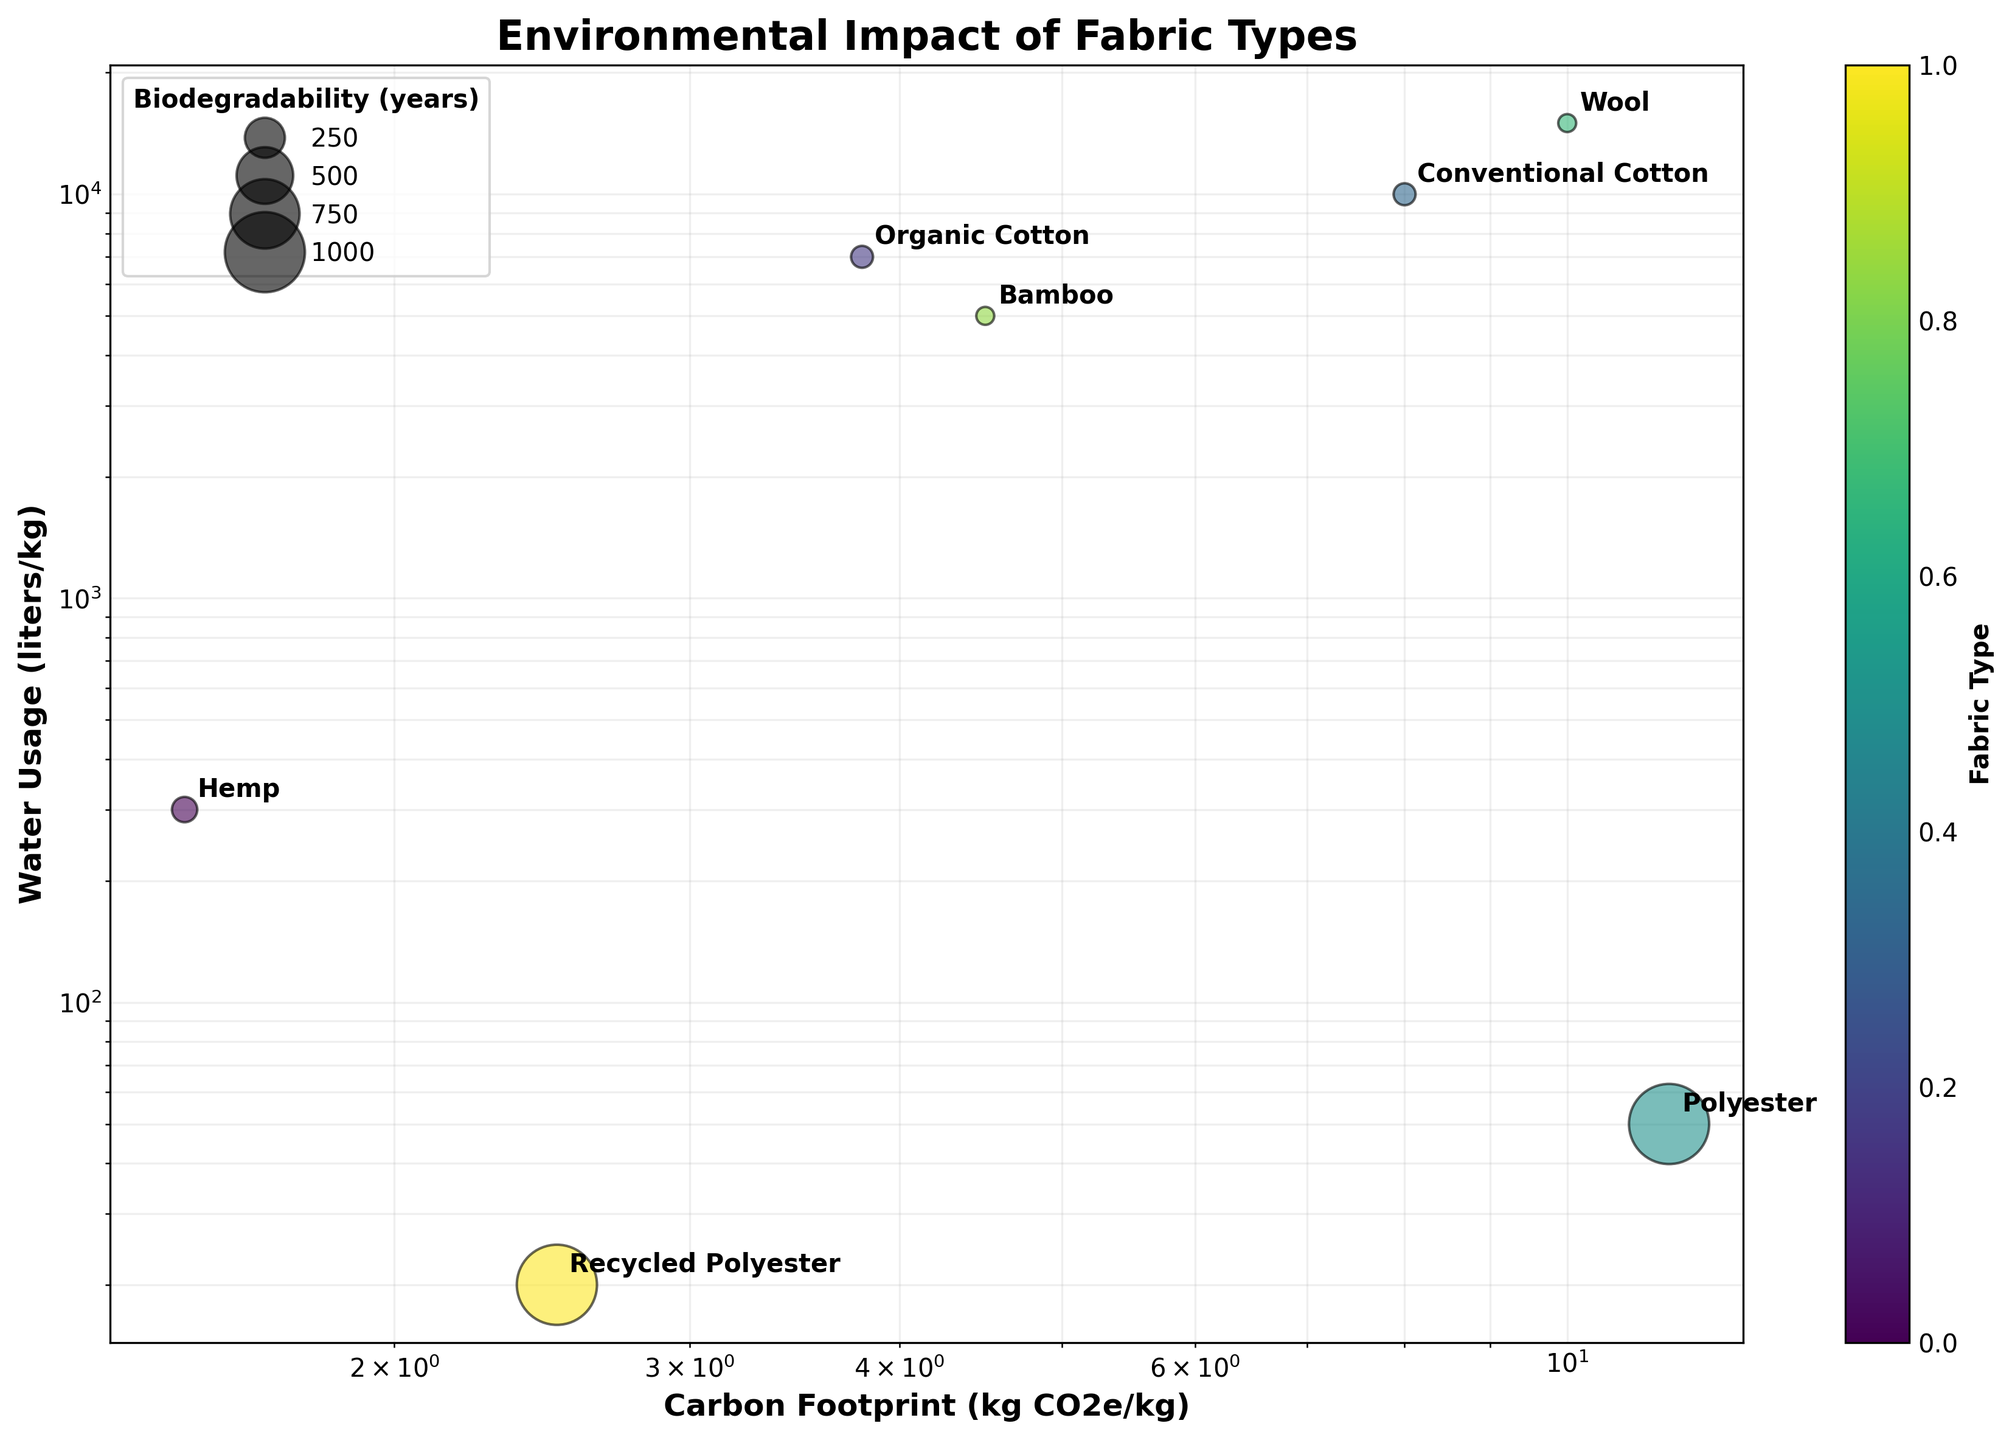What is the title of the chart? The title of the chart is displayed at the top, it reads "Environmental Impact of Fabric Types".
Answer: Environmental Impact of Fabric Types How many fabric types are displayed in the chart? The chart annotates labels for each fabric type, revealing a total of seven different fabrics.
Answer: Seven Which fabric type has the lowest carbon footprint? By observing the x-axis (Carbon Footprint) and checking the points, Hemp, with a carbon footprint of 1.5 kg CO2e/kg, is the lowest.
Answer: Hemp Which fabric type uses the most water? By observing the y-axis (Water Usage) and checking the points, Wool, with 15,000 liters/kg, uses the most water.
Answer: Wool Comparing Hemp and Conventional Cotton, which has a higher carbon footprint and by how much? Hemp has a carbon footprint of 1.5 kg CO2e/kg, and Conventional Cotton has 8 kg CO2e/kg. The difference is 8 - 1.5 = 6.5 kg CO2e/kg.
Answer: Conventional Cotton by 6.5 kg CO2e/kg Which fabric type has the highest biodegradability and what is its value? The bubble sizes indicate biodegradability; Polyester and Recycled Polyester appear largest, both at 20 years.
Answer: Polyester and Recycled Polyester; 20 years What is the average water usage of Hemp, Organic Cotton, and Polyester? Sum the water usage: 300 + 7000 + 50 = 7350 liters. Divide by 3 for the average: 7350 / 3 = 2450 liters/kg.
Answer: 2450 liters/kg Between Organic Cotton and Bamboo, which has better biodegradability, and by how much? Organic Cotton biodegrades in 1.5 years, while Bamboo takes 1 year. Bamboo has a better biodegradability by 0.5 years (1.5 - 1).
Answer: Bamboo by 0.5 years Which fabric type lies closest to the origin in the chart and what does it imply about its environmental impact? Recycled Polyester is closest to the origin, which indicates it has one of the lowest carbon footprints (2.5 kg CO2e/kg) and water usage (20 liters/kg) among the fabrics listed.
Answer: Recycled Polyester Based on the chart, which fabric type would be the most sustainable considering carbon footprint, water usage, and biodegradability? Hemp has a low carbon footprint (1.5 kg CO2e/kg), uses less water (300 liters/kg), and biodegrades relatively quickly (2 years), making it the most sustainable option.
Answer: Hemp 